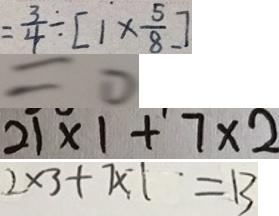<formula> <loc_0><loc_0><loc_500><loc_500>= \frac { 3 } { 4 } \div [ 1 \times \frac { 5 } { 8 } ] 
 = 0 
 2 1 \times 1 + 7 \times 2 
 2 \times 3 + 7 \times 1 = 1 3</formula> 